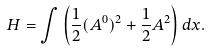<formula> <loc_0><loc_0><loc_500><loc_500>H = \int \left ( \frac { 1 } { 2 } ( A ^ { 0 } ) ^ { 2 } + \frac { 1 } { 2 } A ^ { 2 } \right ) d x .</formula> 